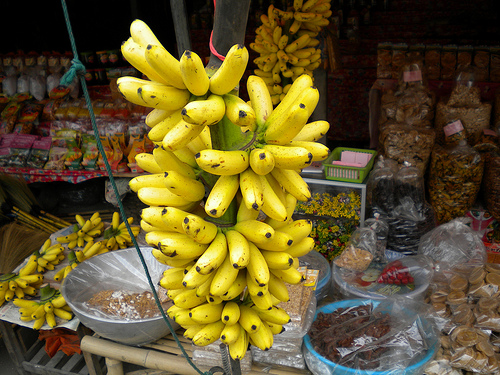Please provide a short description for this region: [0.64, 0.41, 0.76, 0.49]. The specified area highlights a green rectangular basket, possibly hand-woven and used to display produce, contributing to the rustic charm of the market setup. 